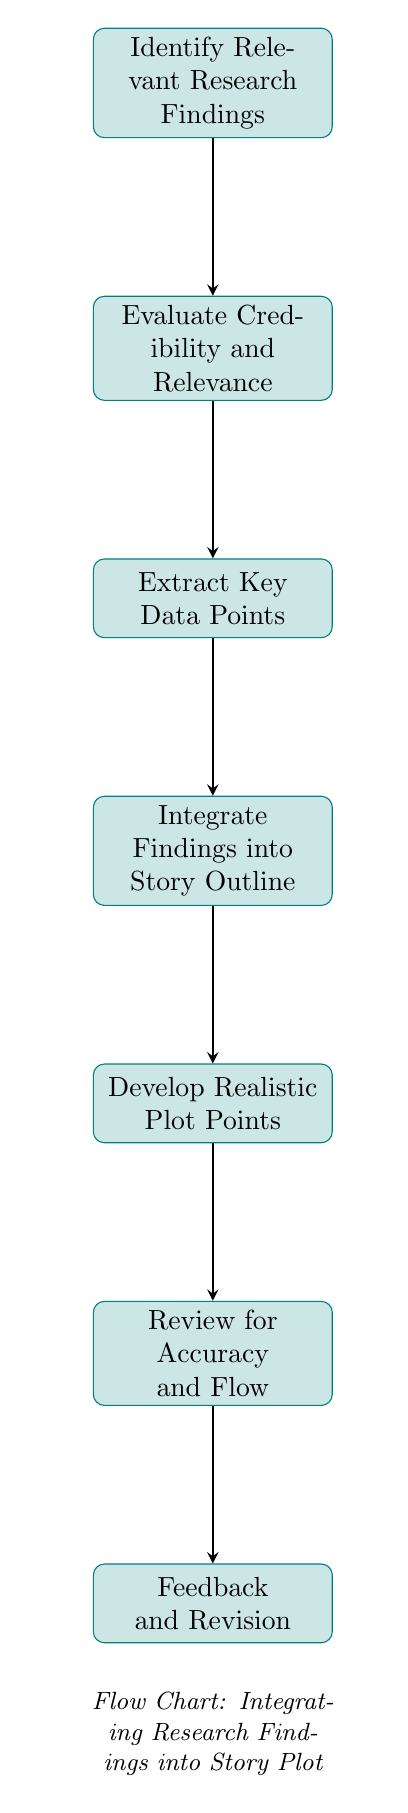What is the first step in the process? The diagram indicates that the first step is "Identify Relevant Research Findings," which is presented as the top node. This step emphasizes the importance of collecting and reviewing recent medical research.
Answer: Identify Relevant Research Findings How many total nodes are in the flow chart? Upon examining the diagram, we can count the total number of nodes listed, which are seven distinct steps in the process.
Answer: 7 Which step follows "Evaluate Credibility and Relevance"? The diagram reveals that the node immediately below "Evaluate Credibility and Relevance" is "Extract Key Data Points," indicating the next step in the procedure.
Answer: Extract Key Data Points What is the final step in the integration process? The last node in the flow chart is labeled "Feedback and Revision," indicating that this is the final step in the procedure for integrating research findings into a story plot.
Answer: Feedback and Revision Which step is directly related to ensuring the story aligns with factual data? The step "Review for Accuracy and Flow" is directly related to ensuring that the story is accurate and well-integrated with the research findings, as highlighted in the flow chart.
Answer: Review for Accuracy and Flow What is the relationship between "Integrate Findings into Story Outline" and "Develop Realistic Plot Points"? In the diagram, "Integrate Findings into Story Outline" leads directly to "Develop Realistic Plot Points," signifying that the integration of research findings serves as a foundation for crafting realistic scenarios in the story.
Answer: They are sequential steps; Integration leads to Development Name a step that involves external feedback in the process. The node "Feedback and Revision" specifically involves obtaining external input or feedback, making it clear that this step is about improving the story based on expert advice.
Answer: Feedback and Revision How does the integration of research findings contribute to plot development? The step "Develop Realistic Plot Points" depends on the earlier integration of research findings, as it uses those findings to create authentic developments and scenarios. This illustrates how research influences storytelling.
Answer: It provides authenticity 